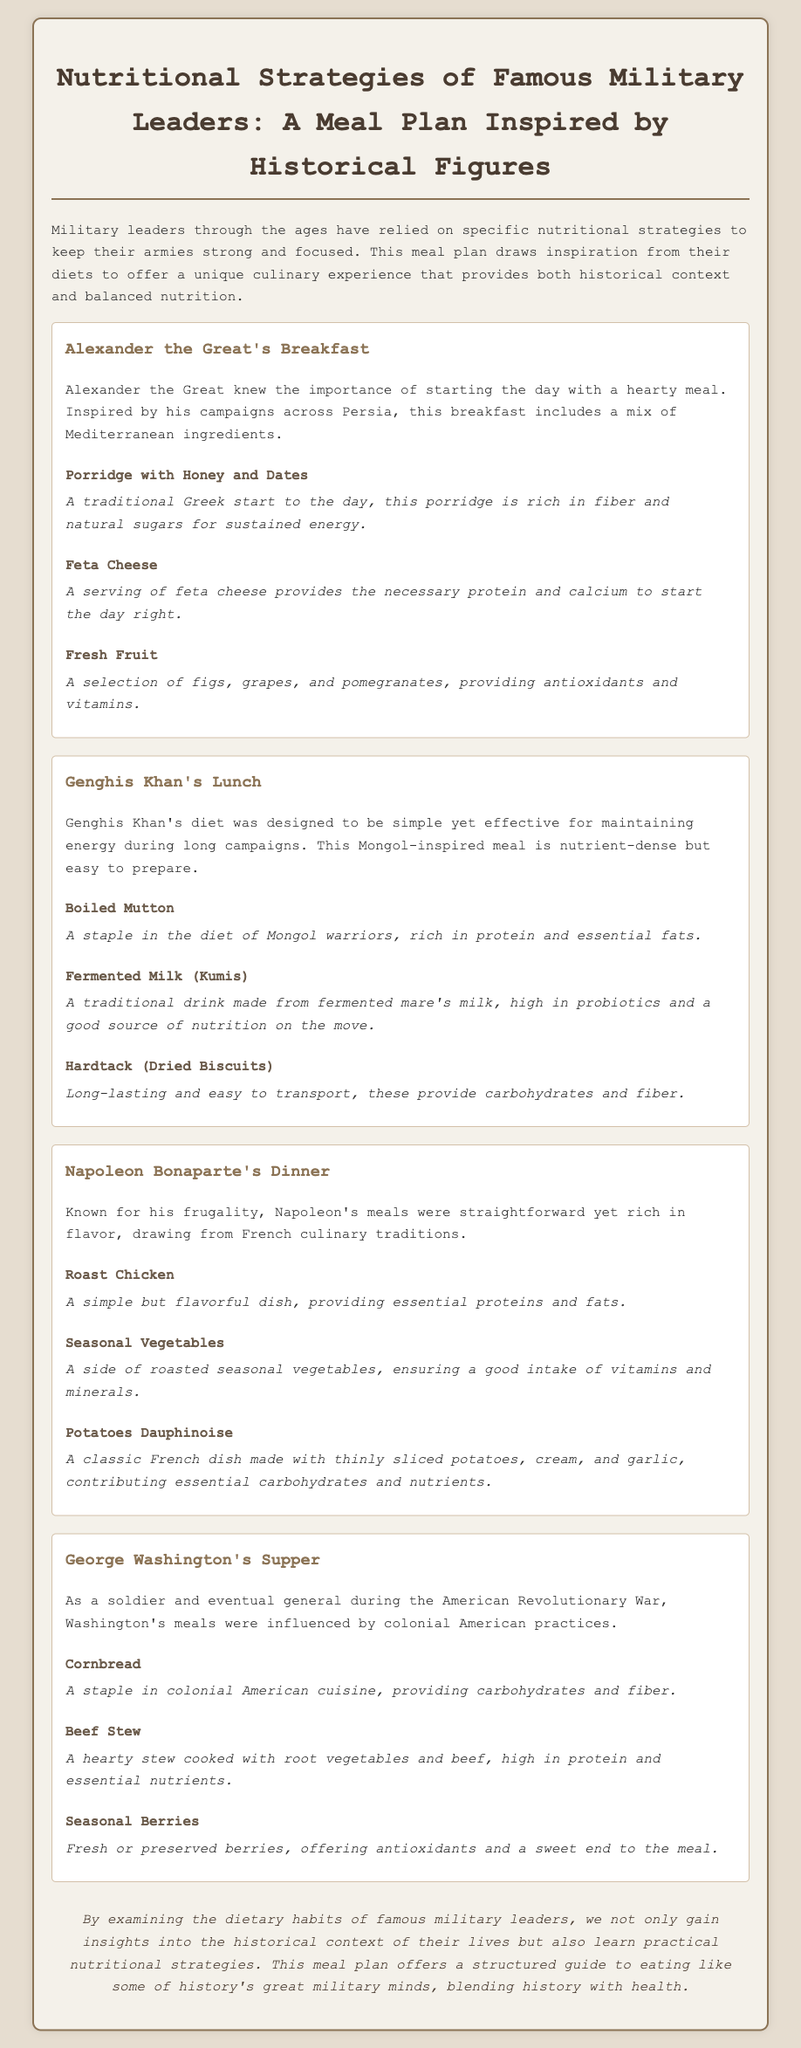What is the title of the document? The title of the document is clearly stated at the top.
Answer: Nutritional Strategies of Famous Military Leaders: A Meal Plan Inspired by Historical Figures What meal does the plan suggest for George Washington? Each section of the document provides a meal associated with a military leader, including George Washington.
Answer: Supper Which fruit is included in Alexander the Great's breakfast? The breakfast section highlights the fresh fruits offered, which are specifically named.
Answer: Figs, grapes, and pomegranates How many meal sections are in the document? By counting the distinct meal sections provided in the document, we can find the total.
Answer: Four What type of drink is suggested in Genghis Khan's lunch? Each meal section describes specific dishes and drinks associated with the historical leader.
Answer: Fermented Milk (Kumis) What is the primary protein source in Napoleon Bonaparte's dinner? The meal section describes the main dish and its contribution to the meal.
Answer: Roast Chicken Which ingredient is used in Napoleon's potatoes dish? The dinner section lists the components of the side dish, clarifying its primary ingredients.
Answer: Cream and garlic What is George Washington's carbohydrate source? The supper section specifically states the carbohydrate-rich food included.
Answer: Cornbread 